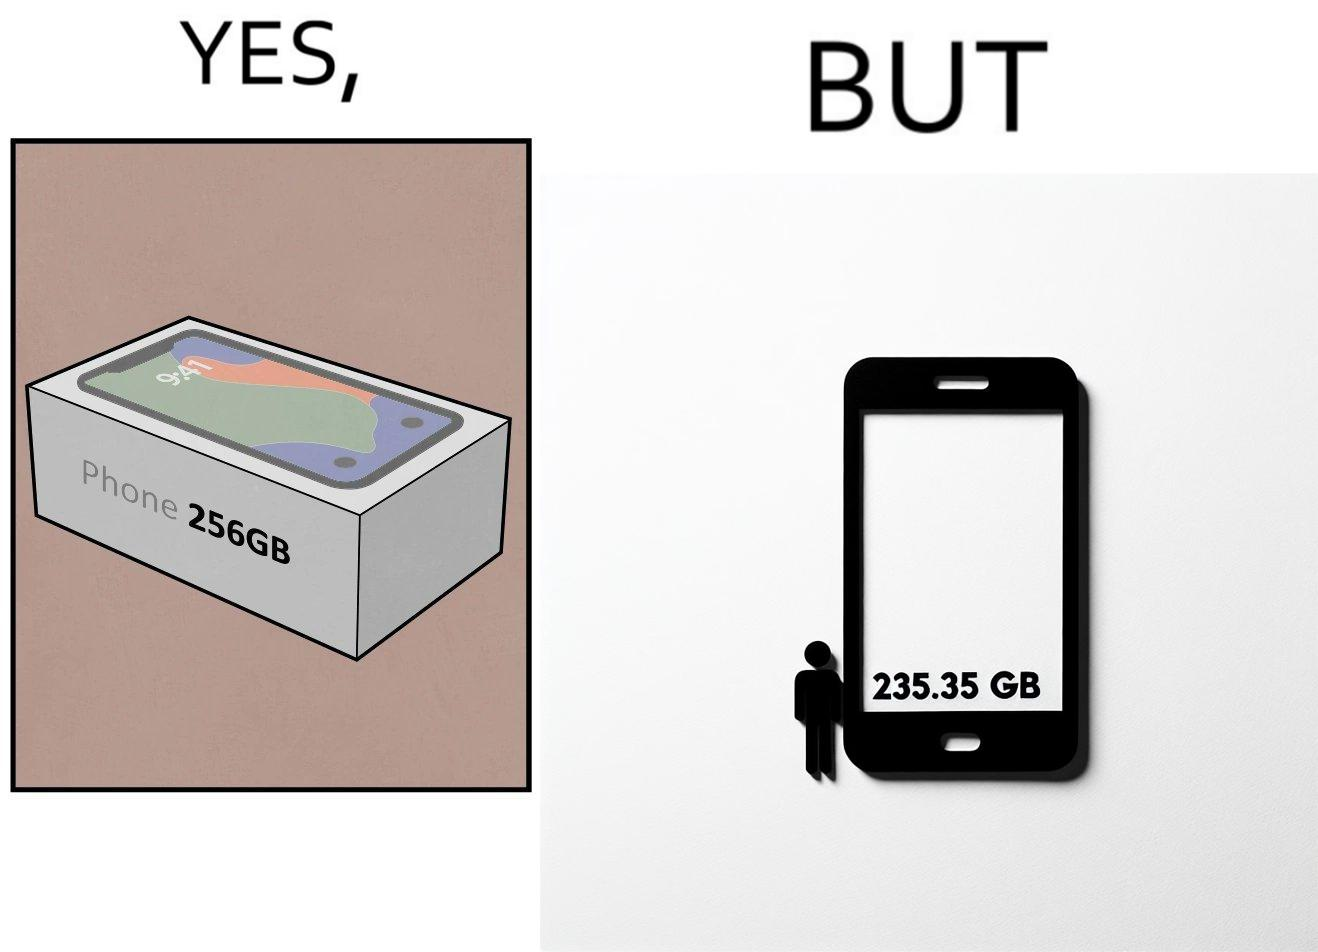Provide a description of this image. The images are funny since they show how smartphone manufacturers advertise their smartphones to have a high internal storage space but in reality, the amount of space available to an user is considerably less due to pre-installed software 